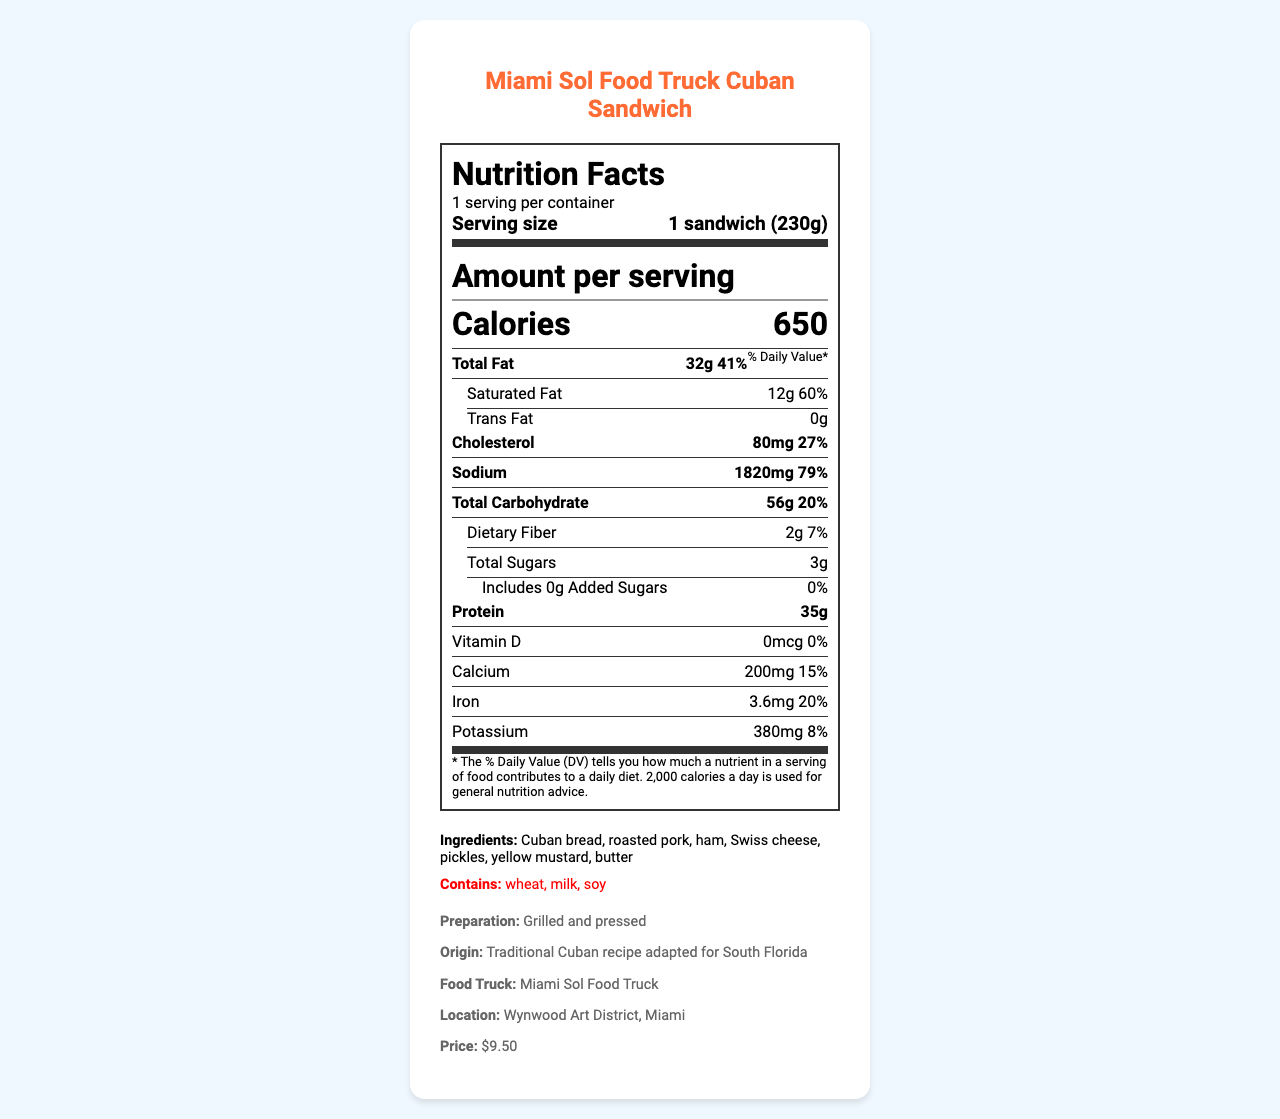what is the serving size for the Cuban sandwich? The serving size is clearly stated as "1 sandwich (230g)" under the servings per container section.
Answer: 1 sandwich (230g) how much sodium does the Cuban sandwich contain? The amount of sodium is listed in the sodium section as 1820 mg.
Answer: 1820 mg what is the daily value percentage for protein? The daily value percentage for protein is shown as 70% in the protein section.
Answer: 70% what are the main ingredients in the Cuban sandwich? The main ingredients are listed under the ingredients section.
Answer: Cuban bread, roasted pork, ham, Swiss cheese, pickles, yellow mustard, butter how many grams of saturated fat are there in the Cuban sandwich? The saturated fat content is shown as 12g under the saturated fat section.
Answer: 12g based on nutrient content, which element has the highest daily value percentage in the Cuban sandwich? A. Cholesterol B. Total fat C. Sodium Sodium has the highest daily value percentage at 79%, compared to 41% for total fat and 27% for cholesterol.
Answer: C. Sodium which nutrient's daily value percentage is the lowest? A. Vitamin D B. Carbohydrate C. Potassium Vitamin D has a daily value percentage of 0%, while carbohydrate has 20% and potassium has 8%.
Answer: A. Vitamin D is there any trans fat in the Cuban sandwich? The trans fat section states that there are 0 grams of trans fat in the Cuban sandwich.
Answer: No does the sandwich contain any allergens? There is an allergen section that lists wheat, milk, and soy as allergens present in the sandwich.
Answer: Yes how would you summarize the nutritional information and other details provided for the Cuban sandwich? The explanation involves summarizing all the key nutritional information, allergens, preparation method, price, and location details provided in the document.
Answer: The document provides detailed nutritional information for the Miami Sol Food Truck Cuban Sandwich, including calorie count, fat content, sodium level, carbohydrate amount, protein amount, and various vitamins and minerals. The sandwich also contains allergens like wheat, milk, and soy. It’s prepared by grilling and pressing and is available for $9.50 at the Miami Sol Food Truck in the Wynwood Art District, Miami. what is the source of this sandwich's origin? The origin information specifies that this sandwich is a traditional Cuban recipe adapted for South Florida.
Answer: Traditional Cuban recipe adapted for South Florida what percentage of daily value does calcium provide? The calcium section shows a daily value of 15% for calcium.
Answer: 15% can you determine the food truck's weekly opening hours from this document? The document does not provide any information related to the food truck's opening hours. It only gives nutritional facts and some additional information like location and price.
Answer: Cannot be determined 